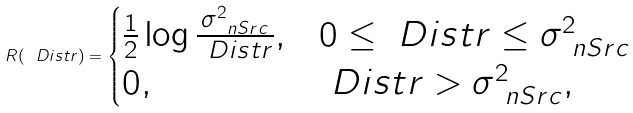<formula> <loc_0><loc_0><loc_500><loc_500>R ( \ D i s t r ) = \begin{cases} \frac { 1 } { 2 } \log \frac { \sigma _ { \ n S r c } ^ { 2 } } { \ D i s t r } , & 0 \leq \ D i s t r \leq \sigma _ { \ n S r c } ^ { 2 } \\ 0 , & \ D i s t r > \sigma _ { \ n S r c } ^ { 2 } , \end{cases}</formula> 